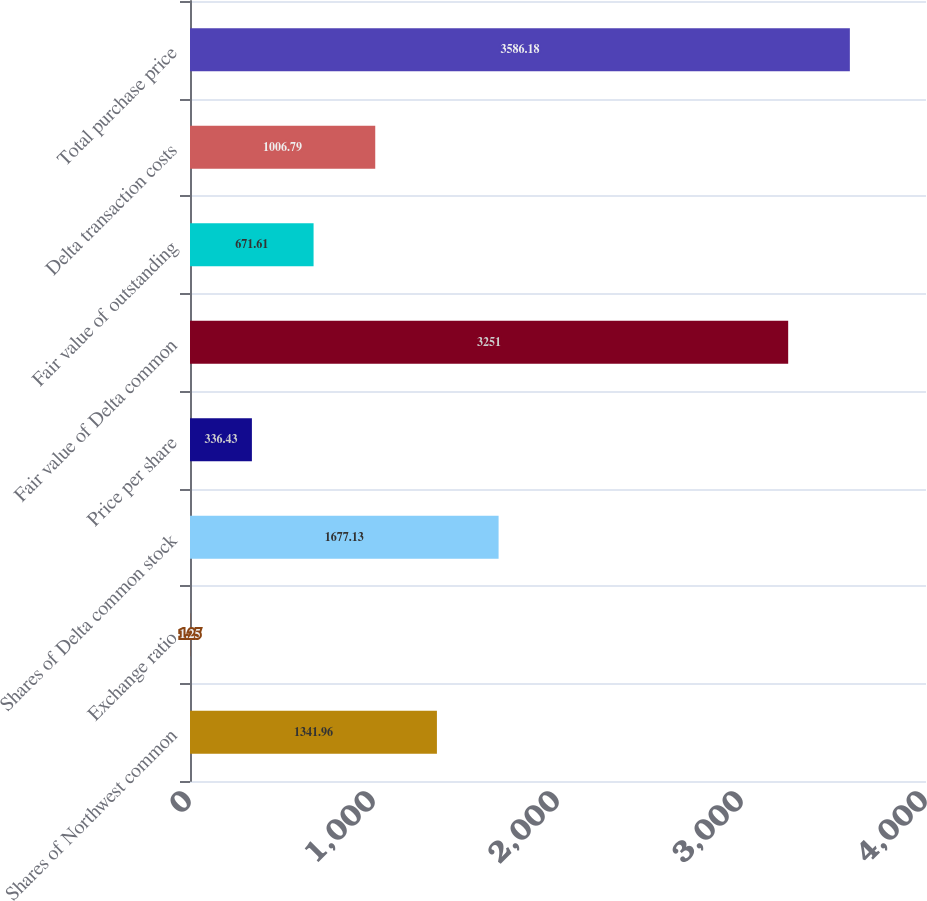Convert chart to OTSL. <chart><loc_0><loc_0><loc_500><loc_500><bar_chart><fcel>Shares of Northwest common<fcel>Exchange ratio<fcel>Shares of Delta common stock<fcel>Price per share<fcel>Fair value of Delta common<fcel>Fair value of outstanding<fcel>Delta transaction costs<fcel>Total purchase price<nl><fcel>1341.96<fcel>1.25<fcel>1677.13<fcel>336.43<fcel>3251<fcel>671.61<fcel>1006.79<fcel>3586.18<nl></chart> 